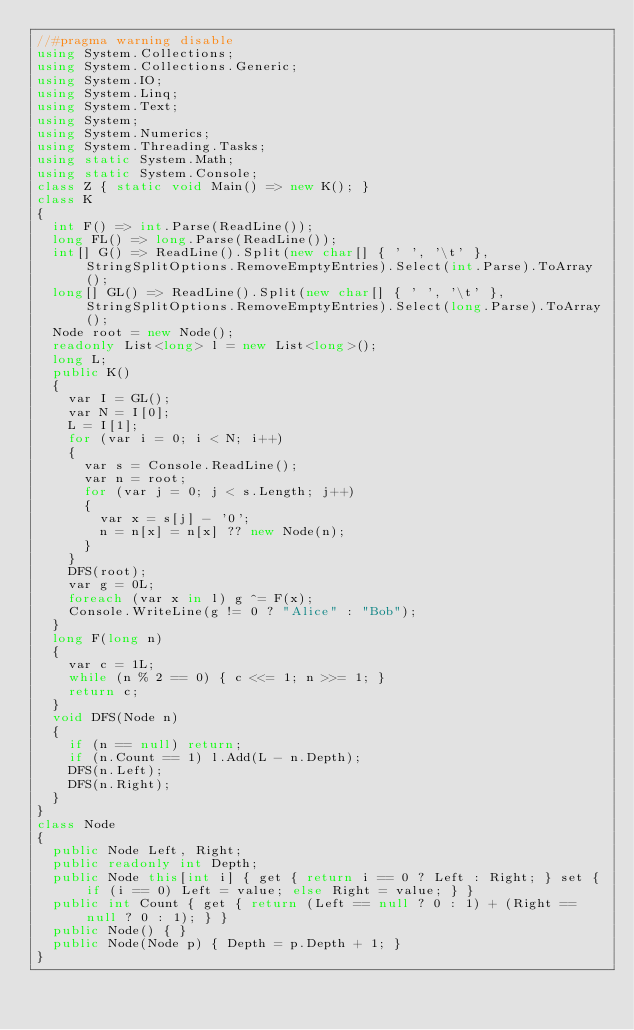Convert code to text. <code><loc_0><loc_0><loc_500><loc_500><_C#_>//#pragma warning disable
using System.Collections;
using System.Collections.Generic;
using System.IO;
using System.Linq;
using System.Text;
using System;
using System.Numerics;
using System.Threading.Tasks;
using static System.Math;
using static System.Console;
class Z { static void Main() => new K(); }
class K
{
	int F() => int.Parse(ReadLine());
	long FL() => long.Parse(ReadLine());
	int[] G() => ReadLine().Split(new char[] { ' ', '\t' }, StringSplitOptions.RemoveEmptyEntries).Select(int.Parse).ToArray();
	long[] GL() => ReadLine().Split(new char[] { ' ', '\t' }, StringSplitOptions.RemoveEmptyEntries).Select(long.Parse).ToArray();
	Node root = new Node();
	readonly List<long> l = new List<long>();
	long L;
	public K()
	{
		var I = GL();
		var N = I[0];
		L = I[1];
		for (var i = 0; i < N; i++)
		{
			var s = Console.ReadLine();
			var n = root;
			for (var j = 0; j < s.Length; j++)
			{
				var x = s[j] - '0';
				n = n[x] = n[x] ?? new Node(n);
			}
		}
		DFS(root);
		var g = 0L;
		foreach (var x in l) g ^= F(x);
		Console.WriteLine(g != 0 ? "Alice" : "Bob");
	}
	long F(long n)
	{
		var c = 1L;
		while (n % 2 == 0) { c <<= 1; n >>= 1; }
		return c;
	}
	void DFS(Node n)
	{
		if (n == null) return;
		if (n.Count == 1) l.Add(L - n.Depth);
		DFS(n.Left);
		DFS(n.Right);
	}
}
class Node
{
	public Node Left, Right;
	public readonly int Depth;
	public Node this[int i] { get { return i == 0 ? Left : Right; } set { if (i == 0) Left = value; else Right = value; } }
	public int Count { get { return (Left == null ? 0 : 1) + (Right == null ? 0 : 1); } }
	public Node() { }
	public Node(Node p) { Depth = p.Depth + 1; }
}
</code> 